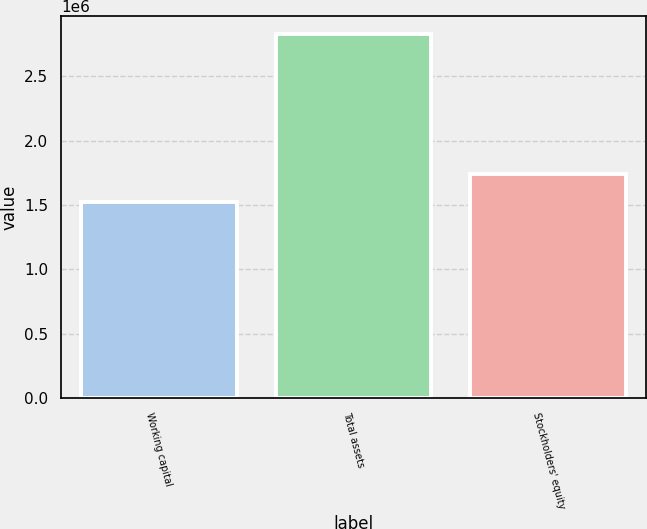<chart> <loc_0><loc_0><loc_500><loc_500><bar_chart><fcel>Working capital<fcel>Total assets<fcel>Stockholders' equity<nl><fcel>1.5194e+06<fcel>2.82552e+06<fcel>1.7379e+06<nl></chart> 